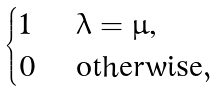<formula> <loc_0><loc_0><loc_500><loc_500>\begin{cases} 1 & \text { $\lambda = \mu$,} \\ 0 & \text { otherwise} , \end{cases}</formula> 